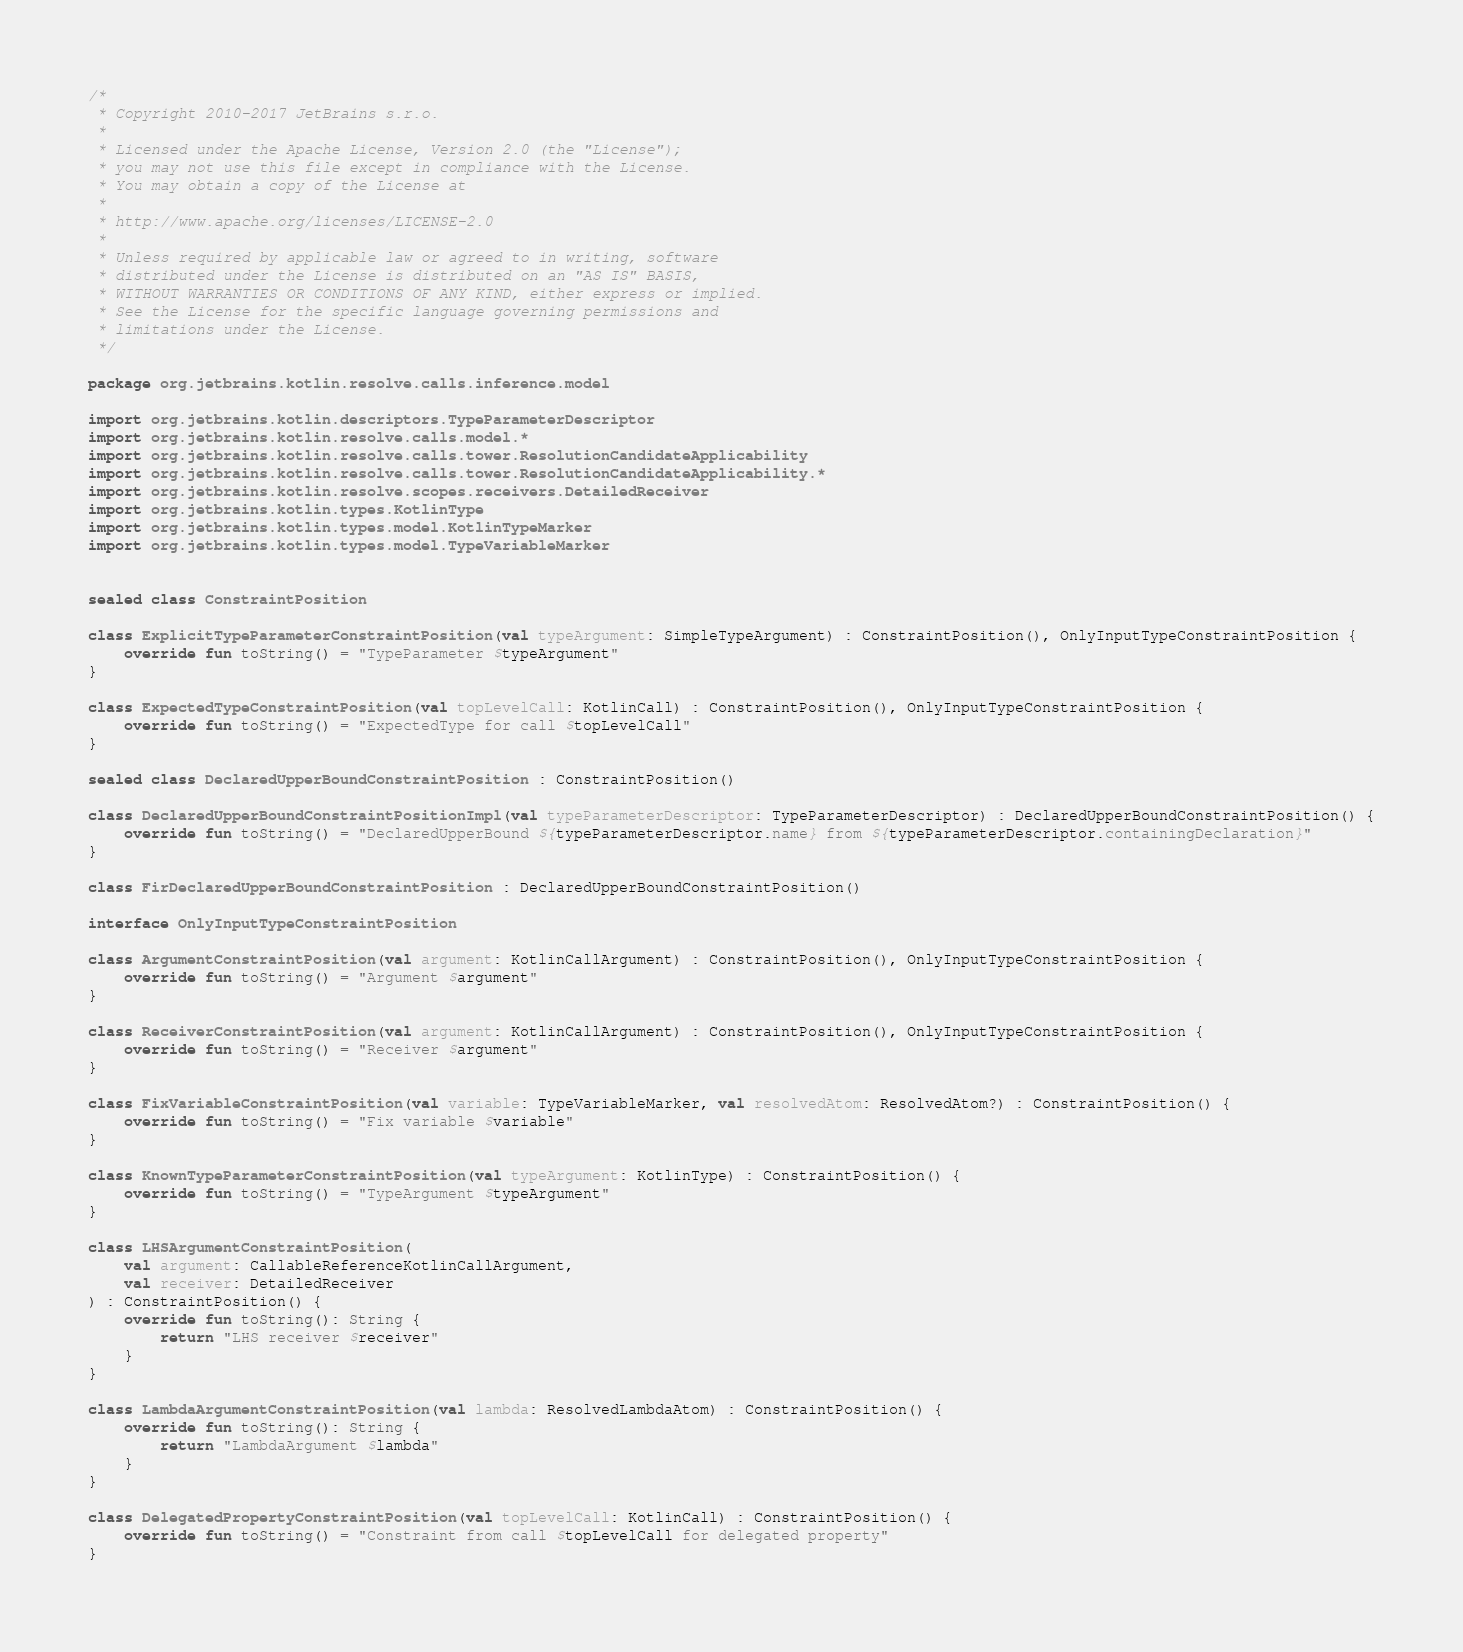<code> <loc_0><loc_0><loc_500><loc_500><_Kotlin_>/*
 * Copyright 2010-2017 JetBrains s.r.o.
 *
 * Licensed under the Apache License, Version 2.0 (the "License");
 * you may not use this file except in compliance with the License.
 * You may obtain a copy of the License at
 *
 * http://www.apache.org/licenses/LICENSE-2.0
 *
 * Unless required by applicable law or agreed to in writing, software
 * distributed under the License is distributed on an "AS IS" BASIS,
 * WITHOUT WARRANTIES OR CONDITIONS OF ANY KIND, either express or implied.
 * See the License for the specific language governing permissions and
 * limitations under the License.
 */

package org.jetbrains.kotlin.resolve.calls.inference.model

import org.jetbrains.kotlin.descriptors.TypeParameterDescriptor
import org.jetbrains.kotlin.resolve.calls.model.*
import org.jetbrains.kotlin.resolve.calls.tower.ResolutionCandidateApplicability
import org.jetbrains.kotlin.resolve.calls.tower.ResolutionCandidateApplicability.*
import org.jetbrains.kotlin.resolve.scopes.receivers.DetailedReceiver
import org.jetbrains.kotlin.types.KotlinType
import org.jetbrains.kotlin.types.model.KotlinTypeMarker
import org.jetbrains.kotlin.types.model.TypeVariableMarker


sealed class ConstraintPosition

class ExplicitTypeParameterConstraintPosition(val typeArgument: SimpleTypeArgument) : ConstraintPosition(), OnlyInputTypeConstraintPosition {
    override fun toString() = "TypeParameter $typeArgument"
}

class ExpectedTypeConstraintPosition(val topLevelCall: KotlinCall) : ConstraintPosition(), OnlyInputTypeConstraintPosition {
    override fun toString() = "ExpectedType for call $topLevelCall"
}

sealed class DeclaredUpperBoundConstraintPosition : ConstraintPosition()

class DeclaredUpperBoundConstraintPositionImpl(val typeParameterDescriptor: TypeParameterDescriptor) : DeclaredUpperBoundConstraintPosition() {
    override fun toString() = "DeclaredUpperBound ${typeParameterDescriptor.name} from ${typeParameterDescriptor.containingDeclaration}"
}

class FirDeclaredUpperBoundConstraintPosition : DeclaredUpperBoundConstraintPosition()

interface OnlyInputTypeConstraintPosition

class ArgumentConstraintPosition(val argument: KotlinCallArgument) : ConstraintPosition(), OnlyInputTypeConstraintPosition {
    override fun toString() = "Argument $argument"
}

class ReceiverConstraintPosition(val argument: KotlinCallArgument) : ConstraintPosition(), OnlyInputTypeConstraintPosition {
    override fun toString() = "Receiver $argument"
}

class FixVariableConstraintPosition(val variable: TypeVariableMarker, val resolvedAtom: ResolvedAtom?) : ConstraintPosition() {
    override fun toString() = "Fix variable $variable"
}

class KnownTypeParameterConstraintPosition(val typeArgument: KotlinType) : ConstraintPosition() {
    override fun toString() = "TypeArgument $typeArgument"
}

class LHSArgumentConstraintPosition(
    val argument: CallableReferenceKotlinCallArgument,
    val receiver: DetailedReceiver
) : ConstraintPosition() {
    override fun toString(): String {
        return "LHS receiver $receiver"
    }
}

class LambdaArgumentConstraintPosition(val lambda: ResolvedLambdaAtom) : ConstraintPosition() {
    override fun toString(): String {
        return "LambdaArgument $lambda"
    }
}

class DelegatedPropertyConstraintPosition(val topLevelCall: KotlinCall) : ConstraintPosition() {
    override fun toString() = "Constraint from call $topLevelCall for delegated property"
}
</code> 